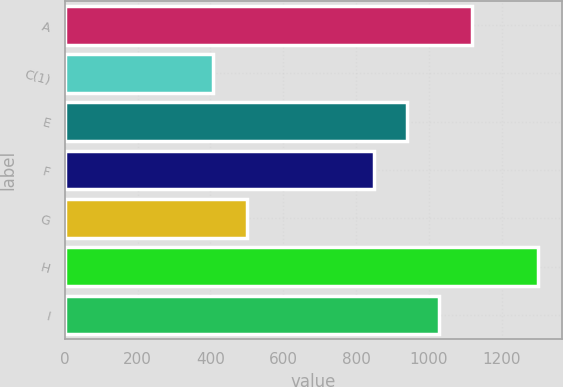Convert chart to OTSL. <chart><loc_0><loc_0><loc_500><loc_500><bar_chart><fcel>A<fcel>C(1)<fcel>E<fcel>F<fcel>G<fcel>H<fcel>I<nl><fcel>1117.6<fcel>408<fcel>939.2<fcel>850<fcel>500<fcel>1300<fcel>1028.4<nl></chart> 